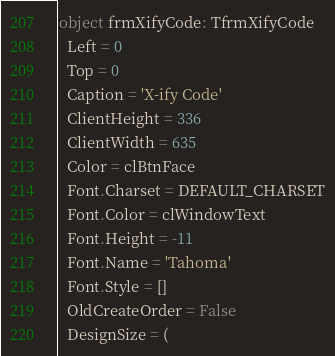<code> <loc_0><loc_0><loc_500><loc_500><_Pascal_>object frmXifyCode: TfrmXifyCode
  Left = 0
  Top = 0
  Caption = 'X-ify Code'
  ClientHeight = 336
  ClientWidth = 635
  Color = clBtnFace
  Font.Charset = DEFAULT_CHARSET
  Font.Color = clWindowText
  Font.Height = -11
  Font.Name = 'Tahoma'
  Font.Style = []
  OldCreateOrder = False
  DesignSize = (</code> 